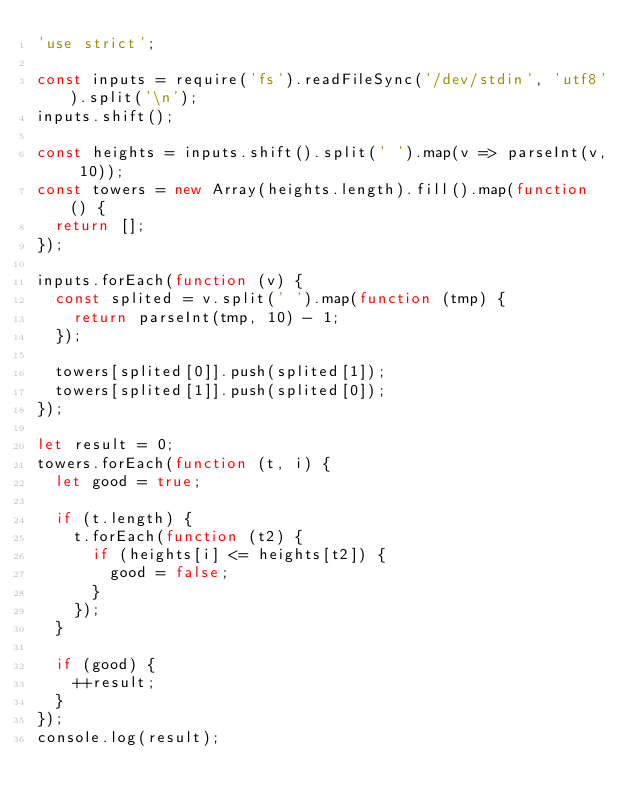<code> <loc_0><loc_0><loc_500><loc_500><_JavaScript_>'use strict';

const inputs = require('fs').readFileSync('/dev/stdin', 'utf8').split('\n');
inputs.shift();

const heights = inputs.shift().split(' ').map(v => parseInt(v, 10));
const towers = new Array(heights.length).fill().map(function () {
  return [];
});

inputs.forEach(function (v) {
  const splited = v.split(' ').map(function (tmp) {
    return parseInt(tmp, 10) - 1;
  });

  towers[splited[0]].push(splited[1]);
  towers[splited[1]].push(splited[0]);
});

let result = 0;
towers.forEach(function (t, i) {
  let good = true;

  if (t.length) {
    t.forEach(function (t2) {
      if (heights[i] <= heights[t2]) {
        good = false;
      }
    });
  }

  if (good) {
    ++result;
  }
});
console.log(result);</code> 